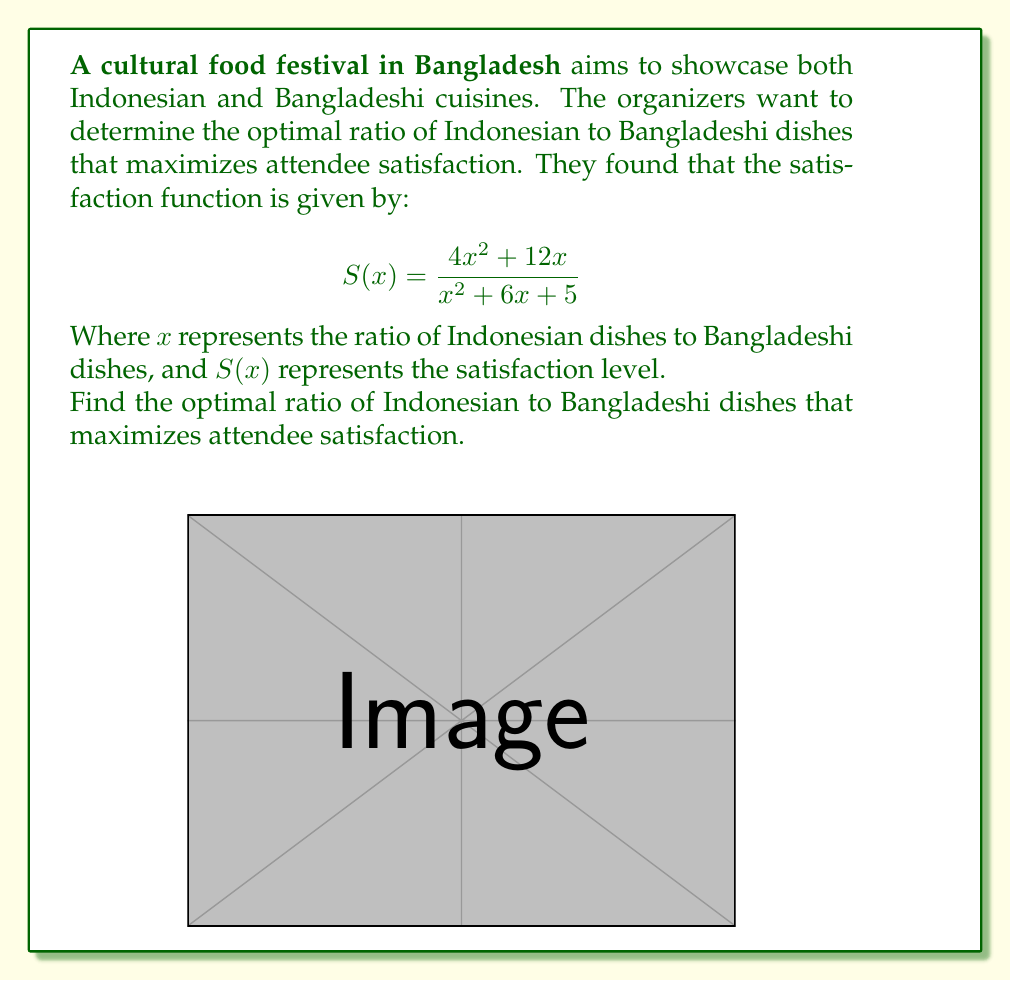Show me your answer to this math problem. To find the optimal ratio, we need to find the maximum value of the satisfaction function $S(x)$. We can do this by following these steps:

1) First, let's find the derivative of $S(x)$ using the quotient rule:

   $$S'(x) = \frac{(x^2 + 6x + 5)(8x + 12) - (4x^2 + 12x)(2x + 6)}{(x^2 + 6x + 5)^2}$$

2) Simplify the numerator:

   $$S'(x) = \frac{8x^3 + 48x^2 + 40x + 12x^2 + 72x + 60 - 8x^3 - 24x^2 - 24x^2 - 72x}{(x^2 + 6x + 5)^2}$$
   
   $$S'(x) = \frac{12x^2 + 40x + 60}{(x^2 + 6x + 5)^2}$$

3) To find the maximum, set $S'(x) = 0$ and solve for $x$:

   $$\frac{12x^2 + 40x + 60}{(x^2 + 6x + 5)^2} = 0$$

4) The denominator is always positive for real $x$, so we only need to solve:

   $$12x^2 + 40x + 60 = 0$$

5) This is a quadratic equation. We can solve it using the quadratic formula:

   $$x = \frac{-b \pm \sqrt{b^2 - 4ac}}{2a}$$

   Where $a = 12$, $b = 40$, and $c = 60$

6) Plugging in these values:

   $$x = \frac{-40 \pm \sqrt{1600 - 2880}}{24} = \frac{-40 \pm \sqrt{-1280}}{24}$$

7) Since we get complex roots, this means there are no real solutions where $S'(x) = 0$. 

8) However, we can see from the graph that the function approaches a horizontal asymptote as $x$ increases. To find this asymptote, we can take the limit as $x$ approaches infinity:

   $$\lim_{x \to \infty} S(x) = \lim_{x \to \infty} \frac{4x^2 + 12x}{x^2 + 6x + 5} = 4$$

9) This means that the satisfaction level approaches 4 as the ratio of Indonesian to Bangladeshi dishes increases.

Therefore, the optimal ratio is to have as many Indonesian dishes as possible compared to Bangladeshi dishes, approaching but never quite reaching a 4:1 ratio.
Answer: Approach a 4:1 ratio of Indonesian to Bangladeshi dishes 